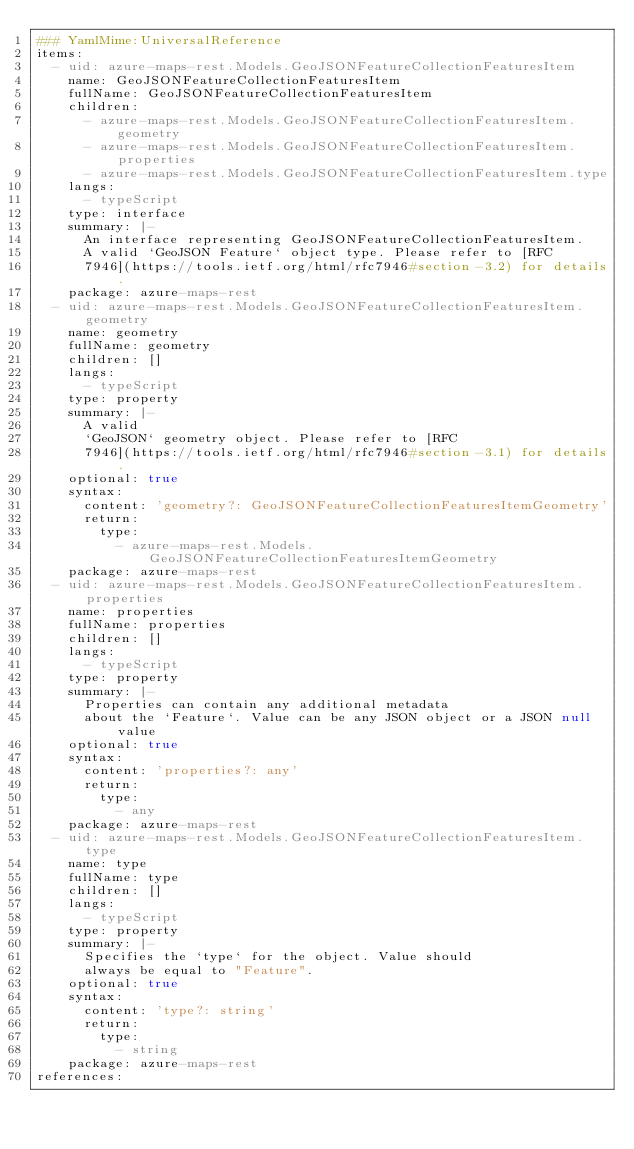<code> <loc_0><loc_0><loc_500><loc_500><_YAML_>### YamlMime:UniversalReference
items:
  - uid: azure-maps-rest.Models.GeoJSONFeatureCollectionFeaturesItem
    name: GeoJSONFeatureCollectionFeaturesItem
    fullName: GeoJSONFeatureCollectionFeaturesItem
    children:
      - azure-maps-rest.Models.GeoJSONFeatureCollectionFeaturesItem.geometry
      - azure-maps-rest.Models.GeoJSONFeatureCollectionFeaturesItem.properties
      - azure-maps-rest.Models.GeoJSONFeatureCollectionFeaturesItem.type
    langs:
      - typeScript
    type: interface
    summary: |-
      An interface representing GeoJSONFeatureCollectionFeaturesItem.
      A valid `GeoJSON Feature` object type. Please refer to [RFC
      7946](https://tools.ietf.org/html/rfc7946#section-3.2) for details.
    package: azure-maps-rest
  - uid: azure-maps-rest.Models.GeoJSONFeatureCollectionFeaturesItem.geometry
    name: geometry
    fullName: geometry
    children: []
    langs:
      - typeScript
    type: property
    summary: |-
      A valid
      `GeoJSON` geometry object. Please refer to [RFC
      7946](https://tools.ietf.org/html/rfc7946#section-3.1) for details.
    optional: true
    syntax:
      content: 'geometry?: GeoJSONFeatureCollectionFeaturesItemGeometry'
      return:
        type:
          - azure-maps-rest.Models.GeoJSONFeatureCollectionFeaturesItemGeometry
    package: azure-maps-rest
  - uid: azure-maps-rest.Models.GeoJSONFeatureCollectionFeaturesItem.properties
    name: properties
    fullName: properties
    children: []
    langs:
      - typeScript
    type: property
    summary: |-
      Properties can contain any additional metadata
      about the `Feature`. Value can be any JSON object or a JSON null value
    optional: true
    syntax:
      content: 'properties?: any'
      return:
        type:
          - any
    package: azure-maps-rest
  - uid: azure-maps-rest.Models.GeoJSONFeatureCollectionFeaturesItem.type
    name: type
    fullName: type
    children: []
    langs:
      - typeScript
    type: property
    summary: |-
      Specifies the `type` for the object. Value should
      always be equal to "Feature".
    optional: true
    syntax:
      content: 'type?: string'
      return:
        type:
          - string
    package: azure-maps-rest
references:</code> 